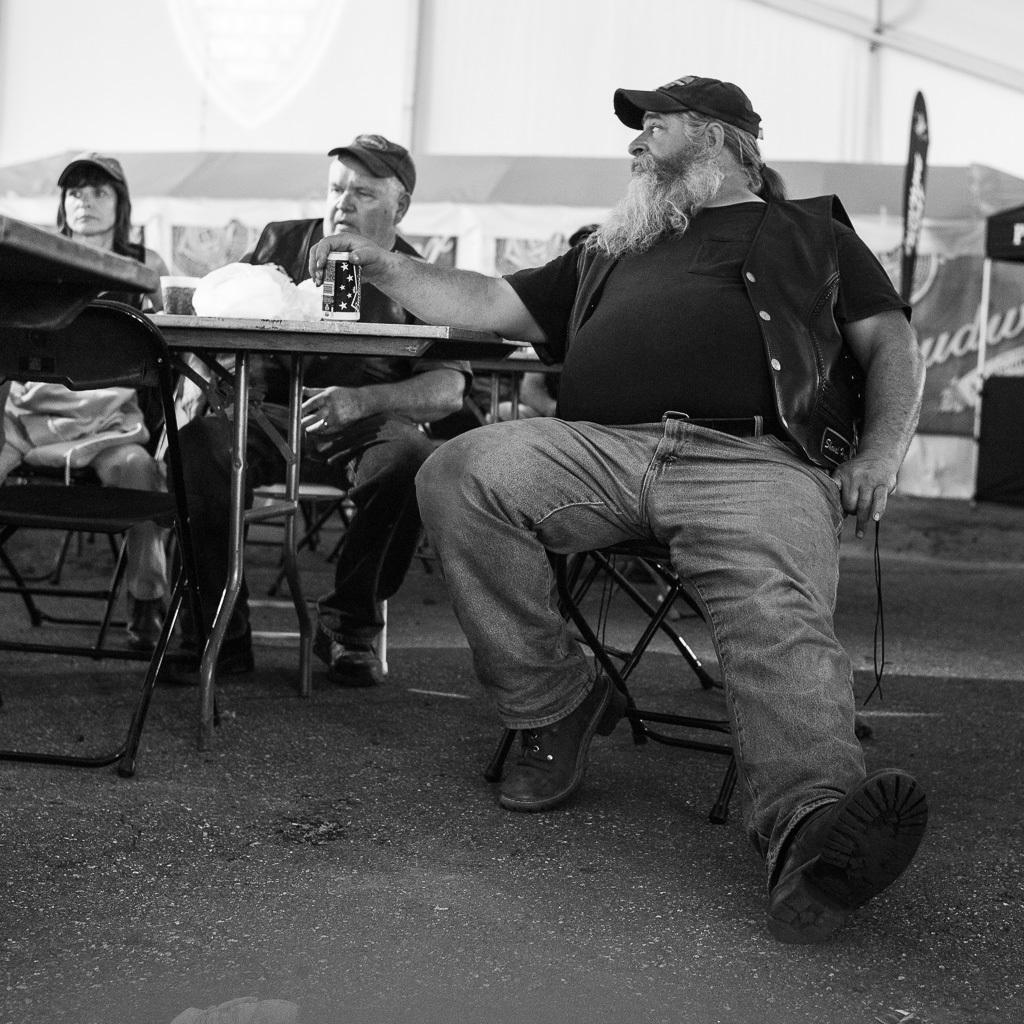How many people are in the image? There are three persons in the image. What are the persons doing in the image? The persons are sitting on chairs. What is present on the table in the image? There is a tin on the table. What can be seen in the background of the image? There is a road visible in the image. What type of question is being asked by the celery in the image? There is no celery present in the image, and therefore no such activity can be observed. Can you tell me how many cannons are visible in the image? There are no cannons present in the image. 